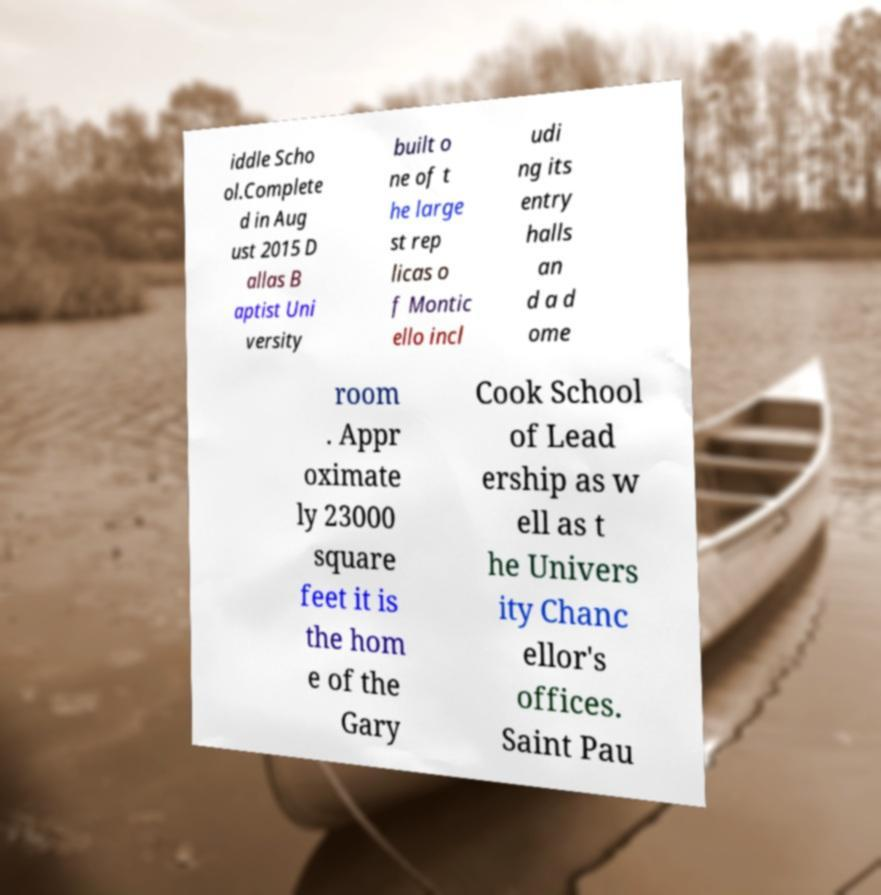Please identify and transcribe the text found in this image. iddle Scho ol.Complete d in Aug ust 2015 D allas B aptist Uni versity built o ne of t he large st rep licas o f Montic ello incl udi ng its entry halls an d a d ome room . Appr oximate ly 23000 square feet it is the hom e of the Gary Cook School of Lead ership as w ell as t he Univers ity Chanc ellor's offices. Saint Pau 